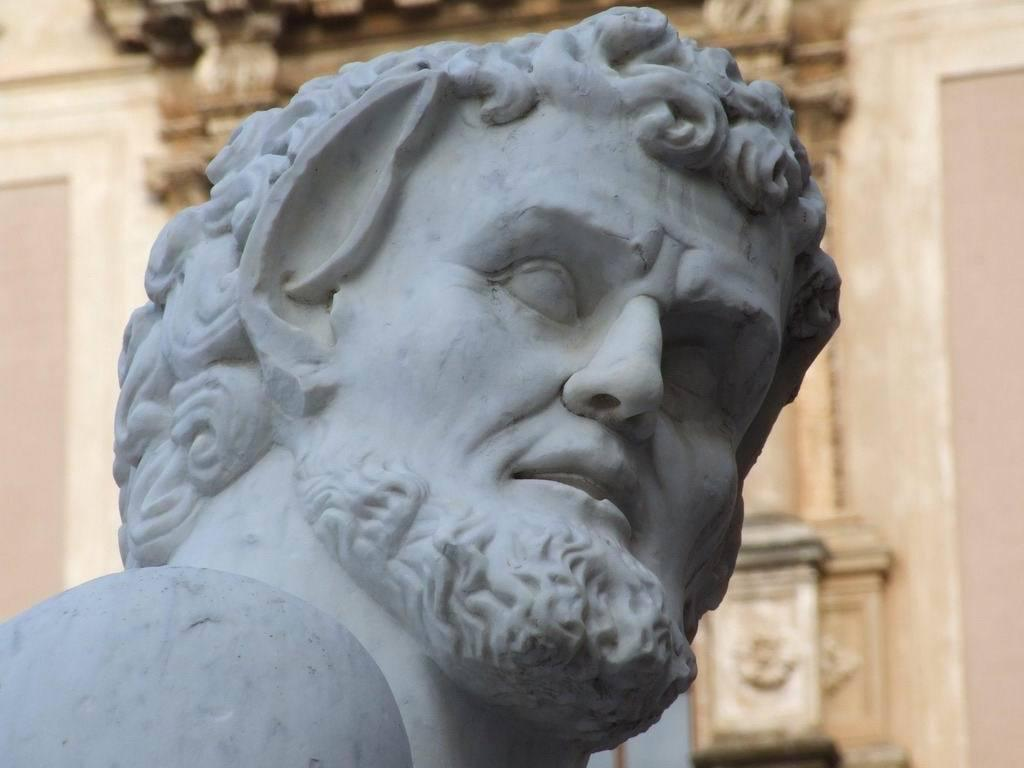What is the main subject of the image? There is a sculpture of a person in the image. What is located behind the sculpture of a person? There is a wall behind the sculpture of a person. How many slaves are depicted in the sculpture in the image? There are no slaves depicted in the sculpture in the image, as the sculpture is of a single person. What idea does the sculpture represent in the image? The image does not provide any information about the idea or concept that the sculpture might represent. 